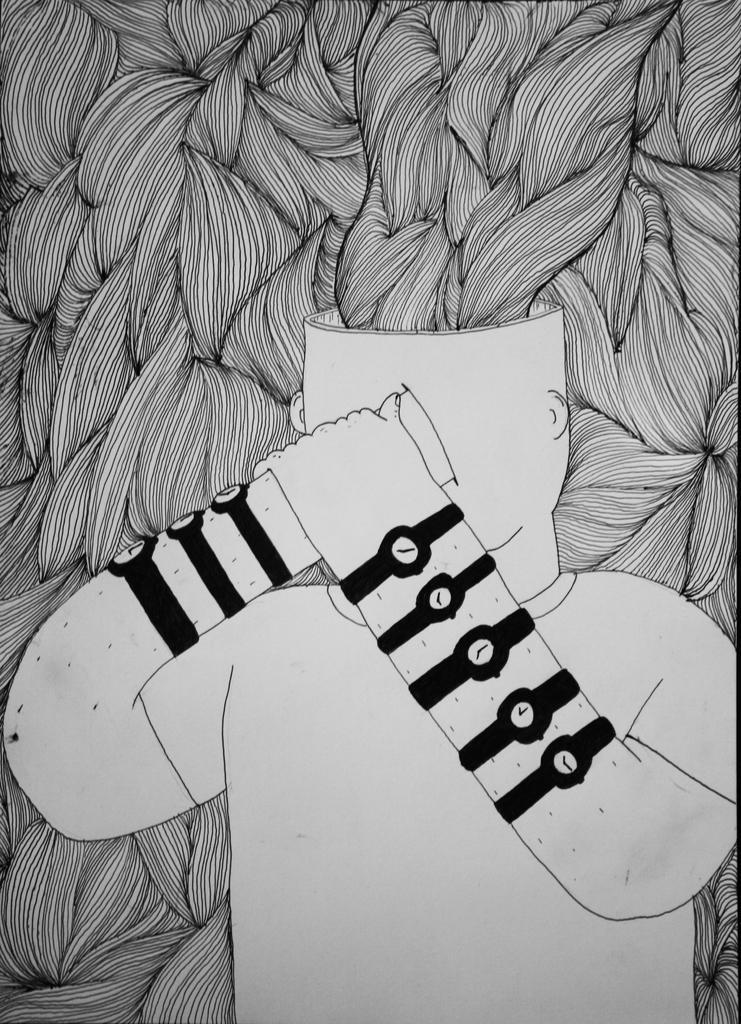Describe this image in one or two sentences. There is a drawing, in which, there is a person, who is placing one hand on his head, on that hand, there is another hand. In the background, there is a design. 